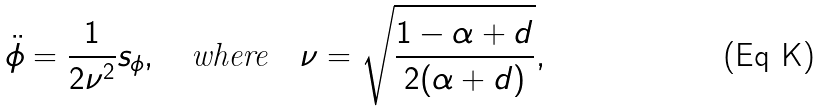Convert formula to latex. <formula><loc_0><loc_0><loc_500><loc_500>\ddot { \phi } = \frac { 1 } { 2 \nu ^ { 2 } } s _ { \phi } , \quad \text {where} \quad \nu = \sqrt { \frac { 1 - \alpha + d } { 2 ( \alpha + d ) } } ,</formula> 